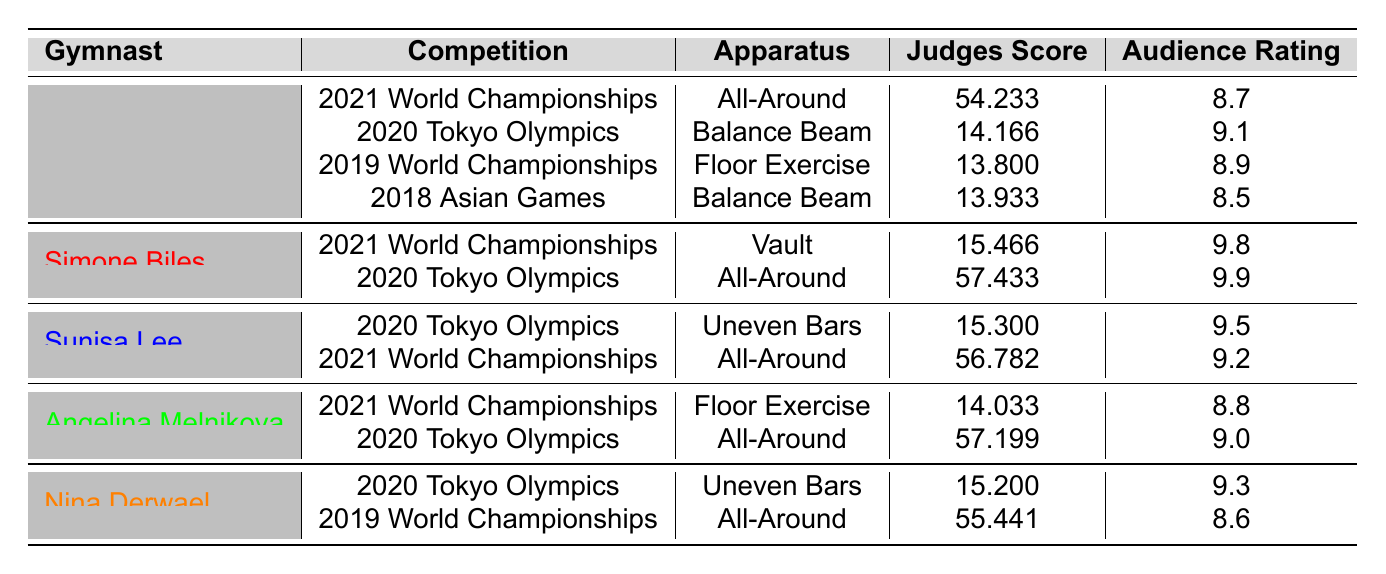What was Jana Mahmoud's judges score in the 2020 Tokyo Olympics? Jana Mahmoud competed in the 2020 Tokyo Olympics on the Balance Beam and received a judges score of 14.166. This information is directly available in the table.
Answer: 14.166 Which gymnast had the highest audience rating in the 2021 World Championships? The table shows that Simone Biles received the highest audience rating of 9.8 in the 2021 World Championships, while Jana Mahmoud had a rating of 8.7.
Answer: Simone Biles What is the average judges score for Jana Mahmoud across all competitions listed? The judges scores for Jana Mahmoud are 54.233, 14.166, 13.800, and 13.933. Adding these scores gives: 54.233 + 14.166 + 13.800 + 13.933 = 96.132. There are 4 scores, so the average is 96.132 / 4 = 24.033.
Answer: 24.033 Did any of the gymnasts receive an audience rating of 9.5? Looking at the audience ratings, Sunisa Lee received a rating of 9.5 during the 2020 Tokyo Olympics. Therefore, the answer is yes.
Answer: Yes What is the difference between the judges score of Simone Biles and Angelina Melnikova in the 2020 Tokyo Olympics? In the 2020 Tokyo Olympics, Simone Biles scored 57.433 and Angelina Melnikova scored 57.199. The difference is 57.433 - 57.199 = 0.234.
Answer: 0.234 Who has the lowest audience rating in the table and what was that rating? Examining the audience ratings, Jana Mahmoud has the lowest rating of 8.5 from the 2018 Asian Games.
Answer: 8.5 How many gymnasts have scored above 15.0 in their judges score in the 2020 Tokyo Olympics according to the table? In the 2020 Tokyo Olympics, the judges scores were as follows: Simone Biles (57.433), Sunisa Lee (15.300), and Nina Derwael (15.200). All of them scored above 15.0. Therefore, there are three gymnasts.
Answer: 3 Which gymnast had a judges score below 14.0 and in which competition did this occur? The table shows that Jana Mahmoud scored 13.800 in the 2019 World Championships for Floor Exercise and also scored 13.933 in the 2018 Asian Games for Balance Beam. Both scores are below 14.0.
Answer: Jana Mahmoud in 2019 World Championships and 2018 Asian Games What was the average audience rating for all the competitions for Nina Derwael? Nina Derwael's audience ratings are 9.3 for the 2020 Tokyo Olympics and 8.6 for the 2019 World Championships. Adding these ratings gives: 9.3 + 8.6 = 17.9. The average is 17.9 / 2 = 8.95.
Answer: 8.95 Is there a competition where Jana Mahmoud's audience rating was higher than her judges score? In the 2020 Tokyo Olympics, Jana Mahmoud's judges score was 14.166 and her audience rating was 9.1, which is higher than the judges score. Therefore, yes, this is true.
Answer: Yes 